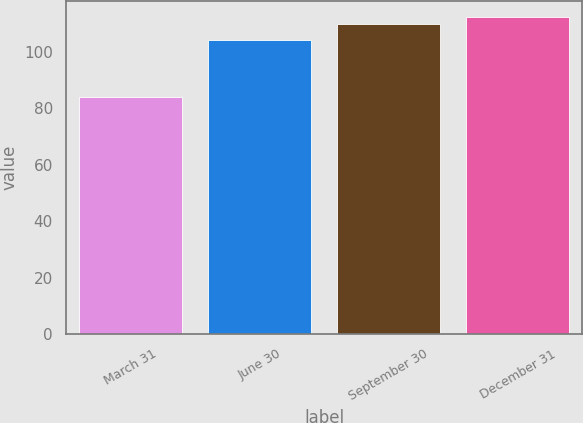Convert chart to OTSL. <chart><loc_0><loc_0><loc_500><loc_500><bar_chart><fcel>March 31<fcel>June 30<fcel>September 30<fcel>December 31<nl><fcel>83.96<fcel>104.25<fcel>109.88<fcel>112.56<nl></chart> 